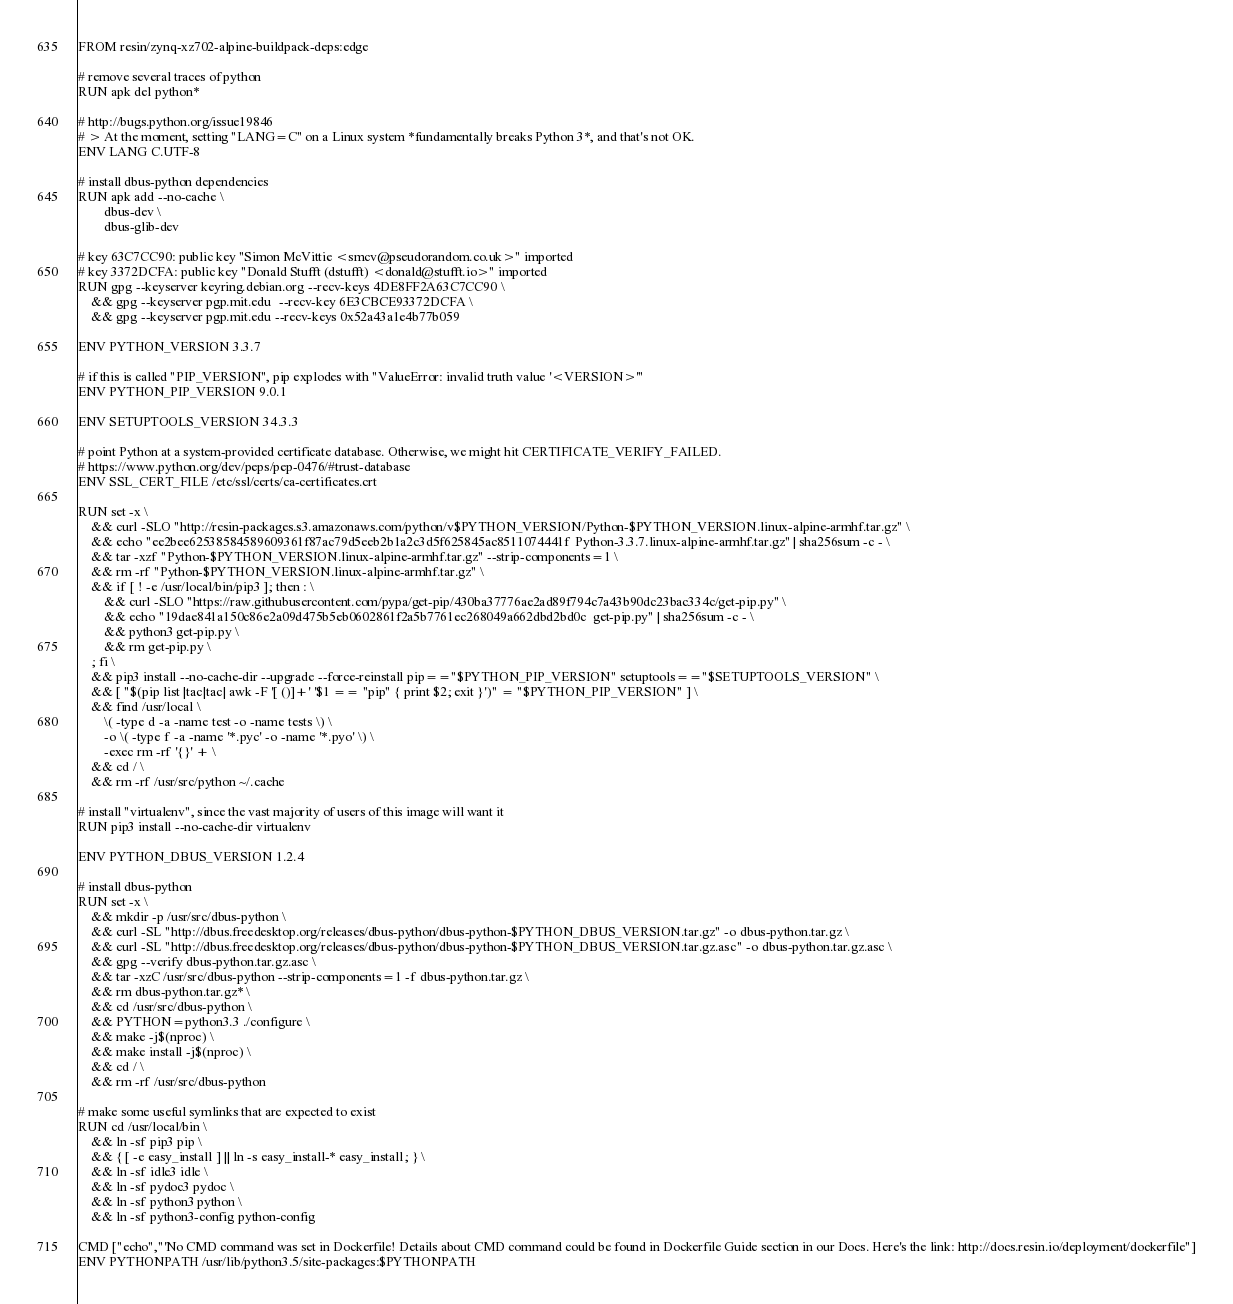<code> <loc_0><loc_0><loc_500><loc_500><_Dockerfile_>FROM resin/zynq-xz702-alpine-buildpack-deps:edge

# remove several traces of python
RUN apk del python*

# http://bugs.python.org/issue19846
# > At the moment, setting "LANG=C" on a Linux system *fundamentally breaks Python 3*, and that's not OK.
ENV LANG C.UTF-8

# install dbus-python dependencies 
RUN apk add --no-cache \
		dbus-dev \
		dbus-glib-dev

# key 63C7CC90: public key "Simon McVittie <smcv@pseudorandom.co.uk>" imported
# key 3372DCFA: public key "Donald Stufft (dstufft) <donald@stufft.io>" imported
RUN gpg --keyserver keyring.debian.org --recv-keys 4DE8FF2A63C7CC90 \
	&& gpg --keyserver pgp.mit.edu  --recv-key 6E3CBCE93372DCFA \
	&& gpg --keyserver pgp.mit.edu --recv-keys 0x52a43a1e4b77b059

ENV PYTHON_VERSION 3.3.7

# if this is called "PIP_VERSION", pip explodes with "ValueError: invalid truth value '<VERSION>'"
ENV PYTHON_PIP_VERSION 9.0.1

ENV SETUPTOOLS_VERSION 34.3.3

# point Python at a system-provided certificate database. Otherwise, we might hit CERTIFICATE_VERIFY_FAILED.
# https://www.python.org/dev/peps/pep-0476/#trust-database
ENV SSL_CERT_FILE /etc/ssl/certs/ca-certificates.crt

RUN set -x \
	&& curl -SLO "http://resin-packages.s3.amazonaws.com/python/v$PYTHON_VERSION/Python-$PYTHON_VERSION.linux-alpine-armhf.tar.gz" \
	&& echo "ee2bee62538584589609361f87ac79d5eeb2b1a2c3d5f625845ac8511074441f  Python-3.3.7.linux-alpine-armhf.tar.gz" | sha256sum -c - \
	&& tar -xzf "Python-$PYTHON_VERSION.linux-alpine-armhf.tar.gz" --strip-components=1 \
	&& rm -rf "Python-$PYTHON_VERSION.linux-alpine-armhf.tar.gz" \
	&& if [ ! -e /usr/local/bin/pip3 ]; then : \
		&& curl -SLO "https://raw.githubusercontent.com/pypa/get-pip/430ba37776ae2ad89f794c7a43b90dc23bac334c/get-pip.py" \
		&& echo "19dae841a150c86e2a09d475b5eb0602861f2a5b7761ec268049a662dbd2bd0c  get-pip.py" | sha256sum -c - \
		&& python3 get-pip.py \
		&& rm get-pip.py \
	; fi \
	&& pip3 install --no-cache-dir --upgrade --force-reinstall pip=="$PYTHON_PIP_VERSION" setuptools=="$SETUPTOOLS_VERSION" \
	&& [ "$(pip list |tac|tac| awk -F '[ ()]+' '$1 == "pip" { print $2; exit }')" = "$PYTHON_PIP_VERSION" ] \
	&& find /usr/local \
		\( -type d -a -name test -o -name tests \) \
		-o \( -type f -a -name '*.pyc' -o -name '*.pyo' \) \
		-exec rm -rf '{}' + \
	&& cd / \
	&& rm -rf /usr/src/python ~/.cache

# install "virtualenv", since the vast majority of users of this image will want it
RUN pip3 install --no-cache-dir virtualenv

ENV PYTHON_DBUS_VERSION 1.2.4

# install dbus-python
RUN set -x \
	&& mkdir -p /usr/src/dbus-python \
	&& curl -SL "http://dbus.freedesktop.org/releases/dbus-python/dbus-python-$PYTHON_DBUS_VERSION.tar.gz" -o dbus-python.tar.gz \
	&& curl -SL "http://dbus.freedesktop.org/releases/dbus-python/dbus-python-$PYTHON_DBUS_VERSION.tar.gz.asc" -o dbus-python.tar.gz.asc \
	&& gpg --verify dbus-python.tar.gz.asc \
	&& tar -xzC /usr/src/dbus-python --strip-components=1 -f dbus-python.tar.gz \
	&& rm dbus-python.tar.gz* \
	&& cd /usr/src/dbus-python \
	&& PYTHON=python3.3 ./configure \
	&& make -j$(nproc) \
	&& make install -j$(nproc) \
	&& cd / \
	&& rm -rf /usr/src/dbus-python

# make some useful symlinks that are expected to exist
RUN cd /usr/local/bin \
	&& ln -sf pip3 pip \
	&& { [ -e easy_install ] || ln -s easy_install-* easy_install; } \
	&& ln -sf idle3 idle \
	&& ln -sf pydoc3 pydoc \
	&& ln -sf python3 python \
	&& ln -sf python3-config python-config

CMD ["echo","'No CMD command was set in Dockerfile! Details about CMD command could be found in Dockerfile Guide section in our Docs. Here's the link: http://docs.resin.io/deployment/dockerfile"]
ENV PYTHONPATH /usr/lib/python3.5/site-packages:$PYTHONPATH
</code> 